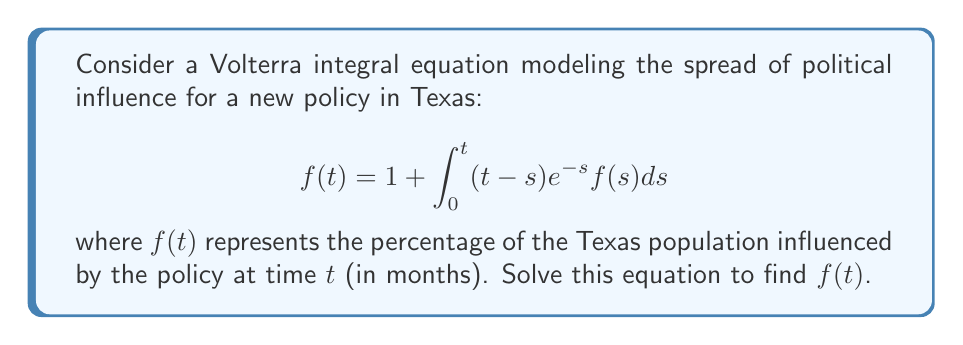Solve this math problem. To solve this Volterra integral equation, we'll use the Laplace transform method:

1) Take the Laplace transform of both sides:
   $$\mathcal{L}\{f(t)\} = \mathcal{L}\{1\} + \mathcal{L}\{\int_0^t (t-s)e^{-s}f(s)ds\}$$

2) Using Laplace transform properties:
   $$F(p) = \frac{1}{p} + \mathcal{L}\{(t-s)e^{-s}\} \cdot F(p)$$

3) Calculate $\mathcal{L}\{(t-s)e^{-s}\}$:
   $$\mathcal{L}\{(t-s)e^{-s}\} = \frac{1}{(p+1)^2}$$

4) Substitute this result:
   $$F(p) = \frac{1}{p} + \frac{1}{(p+1)^2}F(p)$$

5) Solve for $F(p)$:
   $$F(p) - \frac{1}{(p+1)^2}F(p) = \frac{1}{p}$$
   $$F(p)\left(1 - \frac{1}{(p+1)^2}\right) = \frac{1}{p}$$
   $$F(p) = \frac{1}{p} \cdot \frac{(p+1)^2}{(p+1)^2 - 1} = \frac{(p+1)^2}{p((p+1)^2 - 1)}$$

6) Simplify:
   $$F(p) = \frac{(p+1)^2}{p(p^2 + 2p)} = \frac{p+1}{p^2 + 2p} = \frac{1}{p} + \frac{1}{p(p+2)}$$

7) Take the inverse Laplace transform:
   $$f(t) = \mathcal{L}^{-1}\{\frac{1}{p}\} + \mathcal{L}^{-1}\{\frac{1}{p(p+2)}\}$$
   $$f(t) = 1 + \frac{1}{2}(1 - e^{-2t})$$

8) Simplify the final result:
   $$f(t) = \frac{3}{2} - \frac{1}{2}e^{-2t}$$
Answer: $f(t) = \frac{3}{2} - \frac{1}{2}e^{-2t}$ 